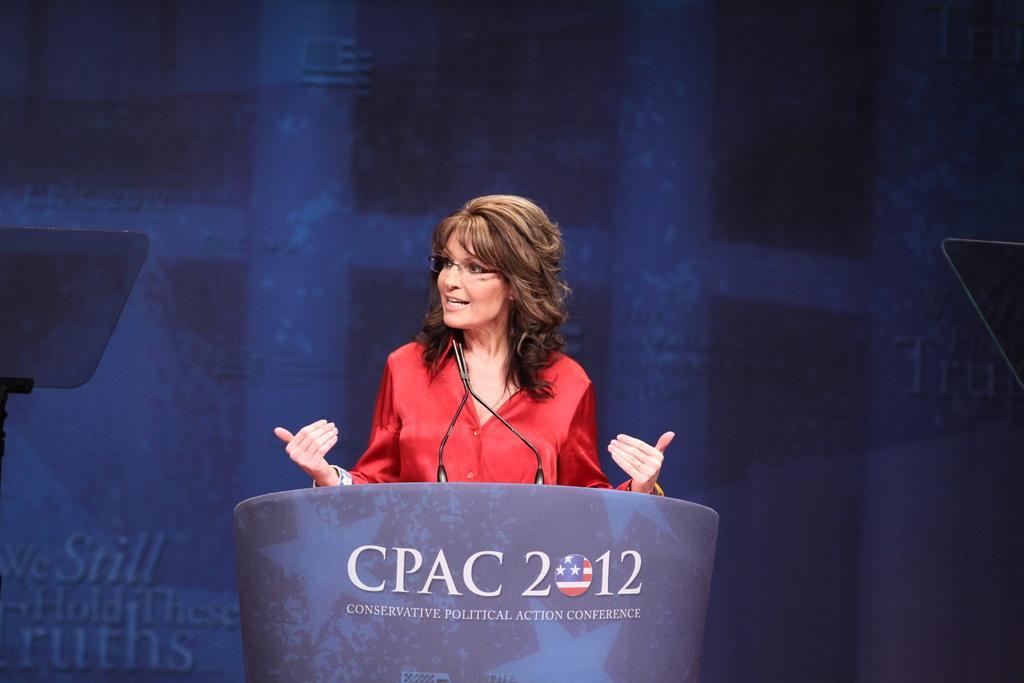In one or two sentences, can you explain what this image depicts? This image consists of a podium. It has the mike. There is a woman in the middle talking, she is a wearing red dress. 